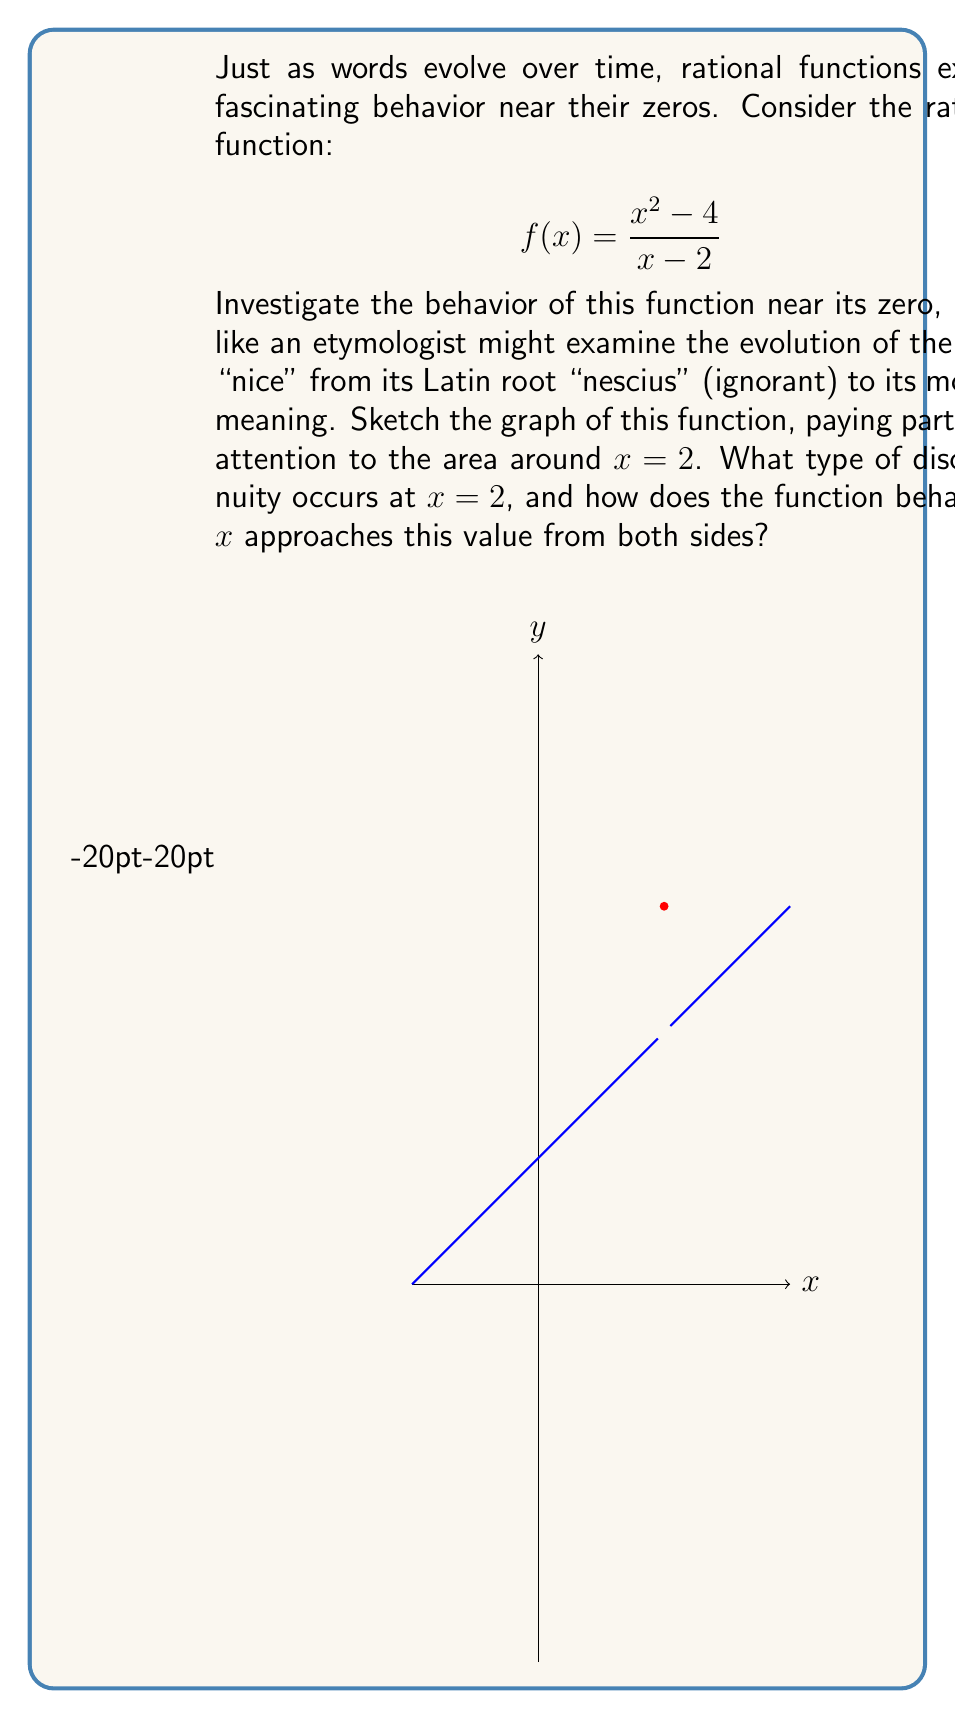Can you answer this question? Let's approach this problem step-by-step, much like tracing the etymology of a word:

1) First, let's factor the numerator of our function:
   $$f(x) = \frac{x^2 - 4}{x - 2} = \frac{(x+2)(x-2)}{x - 2}$$

2) We can now cancel the (x-2) term in both numerator and denominator:
   $$f(x) = x + 2, \text{ for } x \neq 2$$

3) This simplified form reveals that our function is essentially a linear function, except at x = 2 where it's undefined due to division by zero in the original form.

4) To investigate the behavior near x = 2, let's consider the limits:

   As x approaches 2 from the left: 
   $$\lim_{x \to 2^-} f(x) = \lim_{x \to 2^-} (x + 2) = 4$$

   As x approaches 2 from the right:
   $$\lim_{x \to 2^+} f(x) = \lim_{x \to 2^+} (x + 2) = 4$$

5) Since both one-sided limits exist and are equal, the limit as x approaches 2 exists and equals 4.

6) However, f(2) is undefined in the original function due to division by zero.

7) This behavior, where the limit exists but the function is undefined at that point, is characteristic of a removable discontinuity, also known as a "hole" in the graph.

Much like how the word "nice" evolved from meaning "ignorant" to its current positive connotation, our function undergoes a transformation near x = 2. It approaches a specific value (4) from both sides, but has a "gap" or "hole" at exactly x = 2, reminiscent of how words can have gaps in their usage over time before settling into new meanings.
Answer: Removable discontinuity at x = 2 